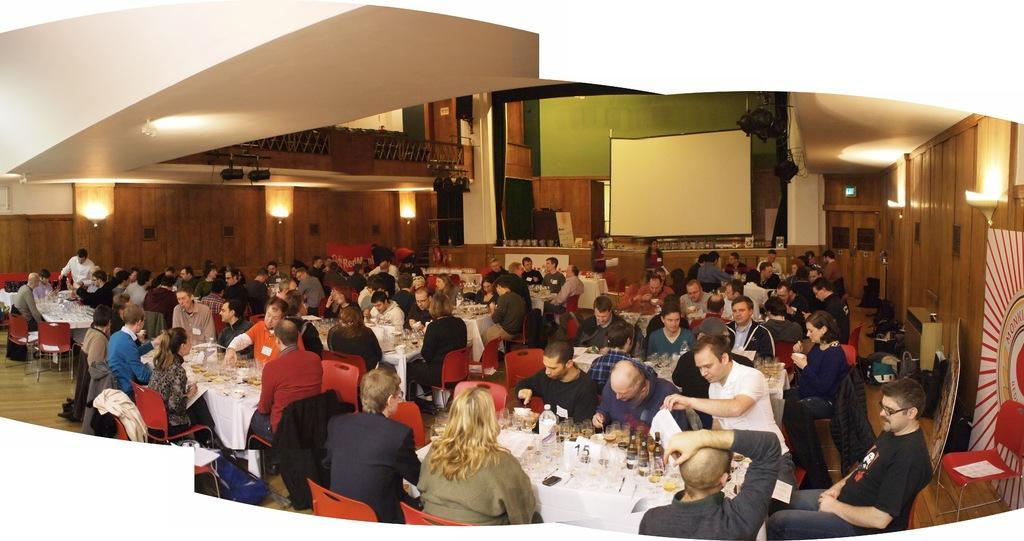How many people are in the image? There is a group of people in the image. What are the people doing in the image? The people are sitting on chairs. Where are the chairs located in relation to the table? The chairs are in front of a table. What can be found on the table in the image? There are objects on the table. What is the large, flat surface in the image used for? There is a projector screen in the image, which is likely used for presentations or displays. What type of trousers are the people wearing in the image? There is no information about the type of trousers the people are wearing in the image. How many yams are on the table in the image? There is no mention of yams in the image; the objects on the table are not specified. 